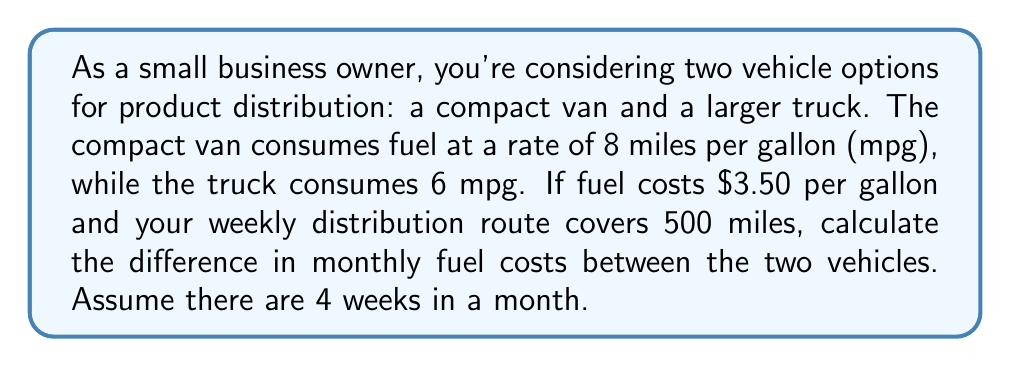Can you answer this question? Let's approach this problem step-by-step:

1. Calculate the weekly fuel consumption for each vehicle:
   - Compact van: $\frac{500 \text{ miles}}{8 \text{ mpg}} = 62.5 \text{ gallons}$
   - Truck: $\frac{500 \text{ miles}}{6 \text{ mpg}} = 83.33 \text{ gallons}$

2. Calculate the weekly fuel cost for each vehicle:
   - Compact van: $62.5 \text{ gallons} \times \$3.50/\text{gallon} = \$218.75$
   - Truck: $83.33 \text{ gallons} \times \$3.50/\text{gallon} = \$291.66$

3. Calculate the monthly fuel cost for each vehicle (4 weeks):
   - Compact van: $\$218.75 \times 4 = \$875$
   - Truck: $\$291.66 \times 4 = \$1,166.64$

4. Calculate the difference in monthly fuel costs:
   $\$1,166.64 - \$875 = \$291.64$

Therefore, the difference in monthly fuel costs between the truck and the compact van is $\$291.64$.
Answer: $\$291.64$ 